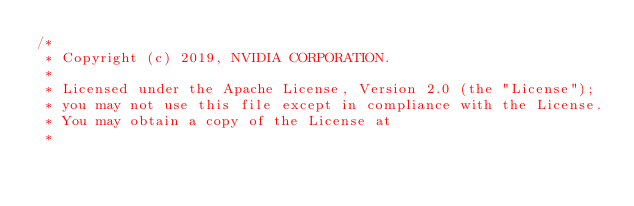<code> <loc_0><loc_0><loc_500><loc_500><_Cuda_>/*
 * Copyright (c) 2019, NVIDIA CORPORATION.
 *
 * Licensed under the Apache License, Version 2.0 (the "License");
 * you may not use this file except in compliance with the License.
 * You may obtain a copy of the License at
 *</code> 